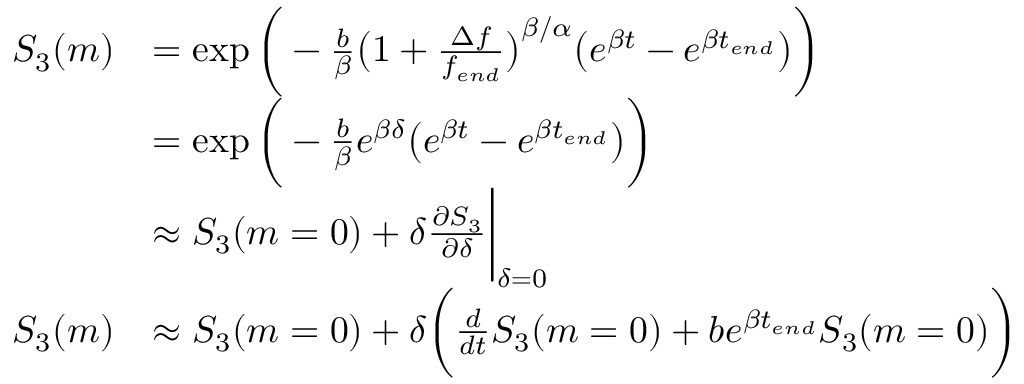Convert formula to latex. <formula><loc_0><loc_0><loc_500><loc_500>\begin{array} { r l } { S _ { 3 } ( m ) } & { = \exp { \Big ( - \frac { b } { \beta } \Big ( 1 + \frac { \Delta f } { { f _ { e n d } } } \Big ) ^ { \beta / \alpha } \Big ( e ^ { \beta t } - e ^ { \beta t _ { e n d } } \Big ) \Big ) } } \\ & { = \exp { \Big ( - \frac { b } { \beta } e ^ { \beta \delta } \Big ( e ^ { \beta t } - e ^ { \beta t _ { e n d } } \Big ) \Big ) } } \\ & { \approx S _ { 3 } ( m = 0 ) + \delta \frac { \partial S _ { 3 } } { \partial \delta } \Big | _ { \delta = 0 } } \\ { S _ { 3 } ( m ) } & { \approx S _ { 3 } ( m = 0 ) + \delta \Big ( \frac { d } { d t } S _ { 3 } ( m = 0 ) + b e ^ { \beta t _ { e n d } } S _ { 3 } ( m = 0 ) \Big ) } \end{array}</formula> 